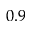<formula> <loc_0><loc_0><loc_500><loc_500>0 . 9</formula> 